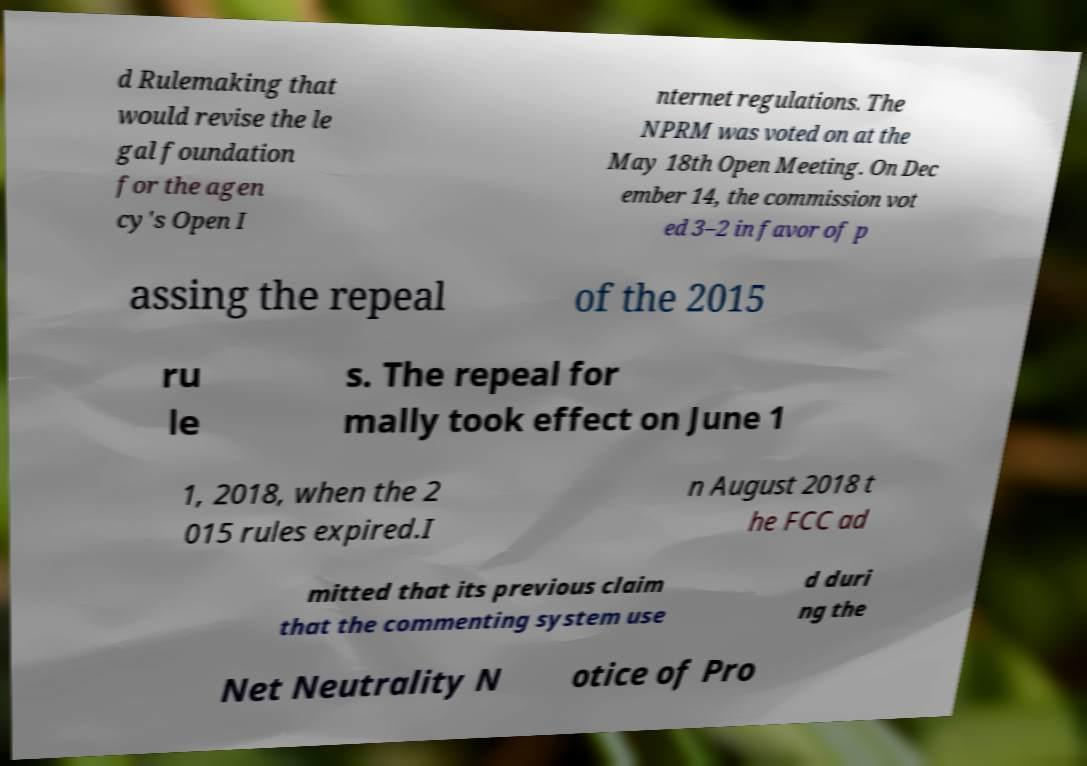Please read and relay the text visible in this image. What does it say? d Rulemaking that would revise the le gal foundation for the agen cy's Open I nternet regulations. The NPRM was voted on at the May 18th Open Meeting. On Dec ember 14, the commission vot ed 3–2 in favor of p assing the repeal of the 2015 ru le s. The repeal for mally took effect on June 1 1, 2018, when the 2 015 rules expired.I n August 2018 t he FCC ad mitted that its previous claim that the commenting system use d duri ng the Net Neutrality N otice of Pro 